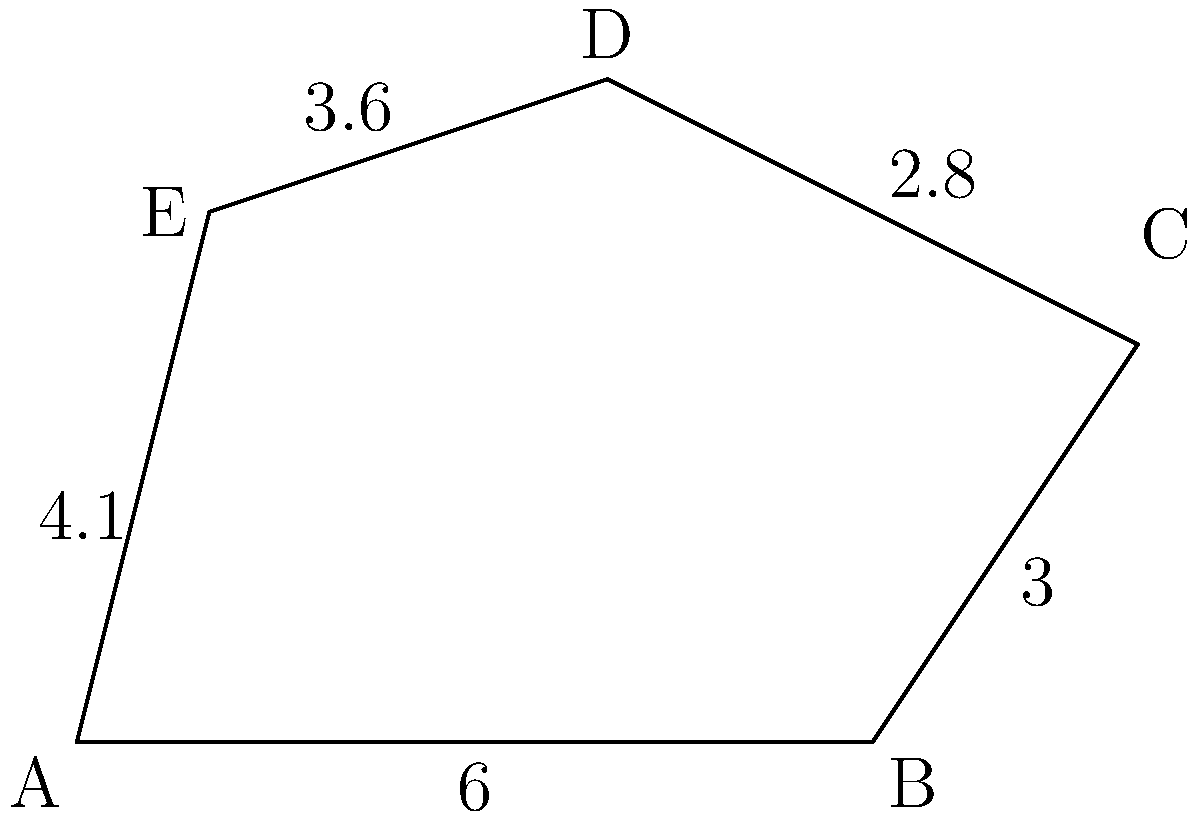The irregular pentagon ABCDE represents the different aspects of a working mother's life. Each side symbolizes a different responsibility: work, childcare, personal time, household chores, and family relationships. If the lengths of the sides are 6 units (AB), 3 units (BC), 2.8 units (CD), 3.6 units (DE), and 4.1 units (EA), what is the total perimeter of the pentagon? This perimeter represents the total effort required to balance all aspects of her life. To find the perimeter of the irregular pentagon, we need to sum up the lengths of all its sides. Let's break it down step by step:

1. Side AB (work): 6 units
2. Side BC (childcare): 3 units
3. Side CD (personal time): 2.8 units
4. Side DE (household chores): 3.6 units
5. Side EA (family relationships): 4.1 units

Now, let's add all these lengths:

$$\text{Perimeter} = AB + BC + CD + DE + EA$$
$$\text{Perimeter} = 6 + 3 + 2.8 + 3.6 + 4.1$$
$$\text{Perimeter} = 19.5 \text{ units}$$

This total represents the combined effort required to manage all aspects of a working mother's life.
Answer: 19.5 units 